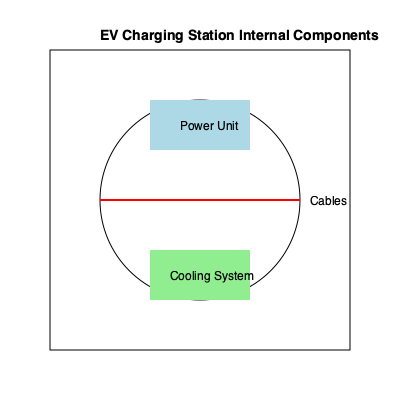In the 3D diagram of an EV charging station's internal components, what is the geometric relationship between the Power Unit and the Cooling System? To determine the geometric relationship between the Power Unit and the Cooling System, we need to analyze their positions within the charging station:

1. The diagram shows a cuboid structure representing the charging station.
2. Inside the cuboid, there's a circular cross-section, likely representing a cylindrical internal structure.
3. The Power Unit is represented by a blue rectangle at the top of the circular cross-section.
4. The Cooling System is represented by a green rectangle at the bottom of the circular cross-section.
5. Both components are positioned along the vertical axis of the cylinder.
6. The red line passing through the center of the circle represents the central axis of the cylindrical structure.
7. The Power Unit and Cooling System are equidistant from this central axis.
8. They are positioned symmetrically on opposite sides of the central axis.

Given this arrangement, we can conclude that the Power Unit and Cooling System are vertically aligned and diametrically opposed within the cylindrical structure of the charging station.
Answer: Vertically aligned and diametrically opposed 